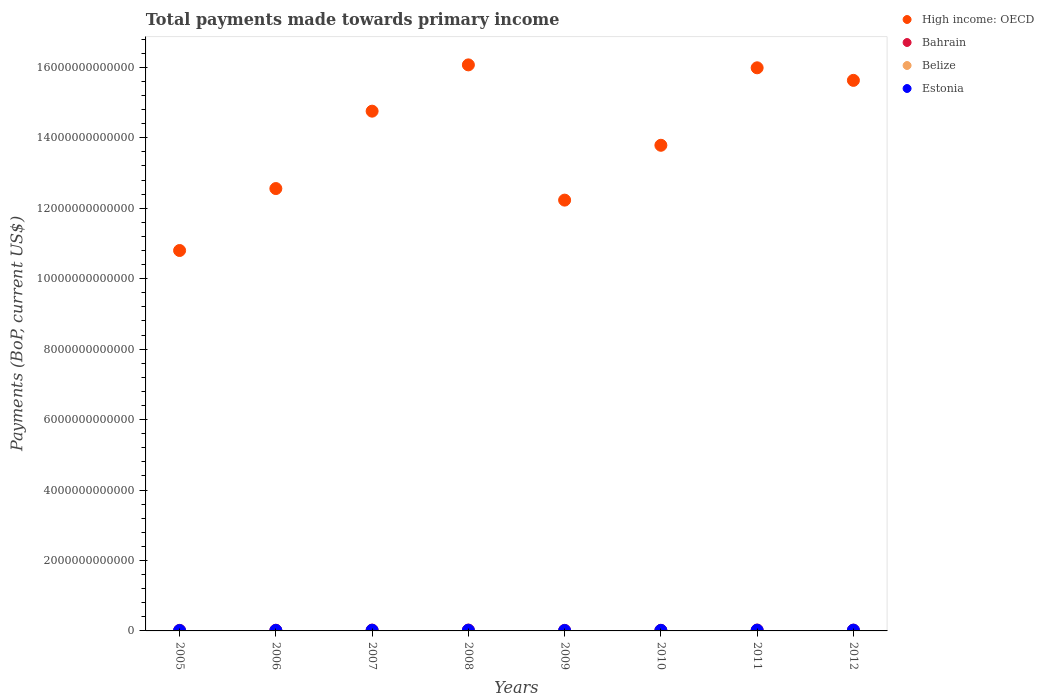What is the total payments made towards primary income in Estonia in 2009?
Make the answer very short. 1.29e+1. Across all years, what is the maximum total payments made towards primary income in Belize?
Give a very brief answer. 1.15e+09. Across all years, what is the minimum total payments made towards primary income in Belize?
Make the answer very short. 8.24e+08. In which year was the total payments made towards primary income in Estonia maximum?
Your response must be concise. 2012. What is the total total payments made towards primary income in Estonia in the graph?
Your answer should be very brief. 1.40e+11. What is the difference between the total payments made towards primary income in Belize in 2008 and that in 2009?
Ensure brevity in your answer.  2.34e+08. What is the difference between the total payments made towards primary income in Belize in 2005 and the total payments made towards primary income in High income: OECD in 2008?
Keep it short and to the point. -1.61e+13. What is the average total payments made towards primary income in Estonia per year?
Make the answer very short. 1.75e+1. In the year 2011, what is the difference between the total payments made towards primary income in Bahrain and total payments made towards primary income in Belize?
Your response must be concise. 2.34e+1. What is the ratio of the total payments made towards primary income in High income: OECD in 2005 to that in 2007?
Provide a succinct answer. 0.73. Is the total payments made towards primary income in High income: OECD in 2005 less than that in 2009?
Make the answer very short. Yes. What is the difference between the highest and the second highest total payments made towards primary income in Belize?
Give a very brief answer. 1.95e+07. What is the difference between the highest and the lowest total payments made towards primary income in High income: OECD?
Provide a succinct answer. 5.27e+12. Is it the case that in every year, the sum of the total payments made towards primary income in Bahrain and total payments made towards primary income in Estonia  is greater than the sum of total payments made towards primary income in High income: OECD and total payments made towards primary income in Belize?
Offer a very short reply. Yes. Does the total payments made towards primary income in High income: OECD monotonically increase over the years?
Offer a very short reply. No. What is the difference between two consecutive major ticks on the Y-axis?
Your response must be concise. 2.00e+12. Where does the legend appear in the graph?
Give a very brief answer. Top right. How are the legend labels stacked?
Make the answer very short. Vertical. What is the title of the graph?
Your answer should be very brief. Total payments made towards primary income. Does "Vanuatu" appear as one of the legend labels in the graph?
Provide a succinct answer. No. What is the label or title of the X-axis?
Your answer should be very brief. Years. What is the label or title of the Y-axis?
Your answer should be compact. Payments (BoP, current US$). What is the Payments (BoP, current US$) of High income: OECD in 2005?
Provide a short and direct response. 1.08e+13. What is the Payments (BoP, current US$) in Bahrain in 2005?
Provide a short and direct response. 1.57e+1. What is the Payments (BoP, current US$) in Belize in 2005?
Give a very brief answer. 8.24e+08. What is the Payments (BoP, current US$) in Estonia in 2005?
Offer a terse response. 1.25e+1. What is the Payments (BoP, current US$) of High income: OECD in 2006?
Your response must be concise. 1.26e+13. What is the Payments (BoP, current US$) in Bahrain in 2006?
Your response must be concise. 1.96e+1. What is the Payments (BoP, current US$) in Belize in 2006?
Offer a very short reply. 8.85e+08. What is the Payments (BoP, current US$) in Estonia in 2006?
Your answer should be compact. 1.56e+1. What is the Payments (BoP, current US$) in High income: OECD in 2007?
Your answer should be compact. 1.48e+13. What is the Payments (BoP, current US$) in Bahrain in 2007?
Provide a succinct answer. 2.33e+1. What is the Payments (BoP, current US$) of Belize in 2007?
Your answer should be very brief. 9.69e+08. What is the Payments (BoP, current US$) of Estonia in 2007?
Give a very brief answer. 1.97e+1. What is the Payments (BoP, current US$) in High income: OECD in 2008?
Your answer should be very brief. 1.61e+13. What is the Payments (BoP, current US$) of Bahrain in 2008?
Your response must be concise. 2.43e+1. What is the Payments (BoP, current US$) of Belize in 2008?
Provide a short and direct response. 1.13e+09. What is the Payments (BoP, current US$) in Estonia in 2008?
Keep it short and to the point. 2.05e+1. What is the Payments (BoP, current US$) in High income: OECD in 2009?
Offer a terse response. 1.22e+13. What is the Payments (BoP, current US$) of Bahrain in 2009?
Keep it short and to the point. 1.54e+1. What is the Payments (BoP, current US$) of Belize in 2009?
Make the answer very short. 8.95e+08. What is the Payments (BoP, current US$) of Estonia in 2009?
Your answer should be very brief. 1.29e+1. What is the Payments (BoP, current US$) of High income: OECD in 2010?
Keep it short and to the point. 1.38e+13. What is the Payments (BoP, current US$) in Bahrain in 2010?
Offer a terse response. 1.69e+1. What is the Payments (BoP, current US$) of Belize in 2010?
Provide a succinct answer. 9.72e+08. What is the Payments (BoP, current US$) in Estonia in 2010?
Make the answer very short. 1.57e+1. What is the Payments (BoP, current US$) of High income: OECD in 2011?
Give a very brief answer. 1.60e+13. What is the Payments (BoP, current US$) in Bahrain in 2011?
Offer a terse response. 2.45e+1. What is the Payments (BoP, current US$) of Belize in 2011?
Your answer should be compact. 1.05e+09. What is the Payments (BoP, current US$) of Estonia in 2011?
Give a very brief answer. 2.14e+1. What is the Payments (BoP, current US$) of High income: OECD in 2012?
Offer a terse response. 1.56e+13. What is the Payments (BoP, current US$) of Bahrain in 2012?
Provide a short and direct response. 2.16e+1. What is the Payments (BoP, current US$) of Belize in 2012?
Make the answer very short. 1.15e+09. What is the Payments (BoP, current US$) of Estonia in 2012?
Provide a short and direct response. 2.21e+1. Across all years, what is the maximum Payments (BoP, current US$) in High income: OECD?
Offer a terse response. 1.61e+13. Across all years, what is the maximum Payments (BoP, current US$) of Bahrain?
Offer a very short reply. 2.45e+1. Across all years, what is the maximum Payments (BoP, current US$) of Belize?
Offer a very short reply. 1.15e+09. Across all years, what is the maximum Payments (BoP, current US$) of Estonia?
Provide a succinct answer. 2.21e+1. Across all years, what is the minimum Payments (BoP, current US$) in High income: OECD?
Offer a terse response. 1.08e+13. Across all years, what is the minimum Payments (BoP, current US$) in Bahrain?
Ensure brevity in your answer.  1.54e+1. Across all years, what is the minimum Payments (BoP, current US$) in Belize?
Keep it short and to the point. 8.24e+08. Across all years, what is the minimum Payments (BoP, current US$) of Estonia?
Make the answer very short. 1.25e+1. What is the total Payments (BoP, current US$) in High income: OECD in the graph?
Provide a succinct answer. 1.12e+14. What is the total Payments (BoP, current US$) of Bahrain in the graph?
Provide a short and direct response. 1.61e+11. What is the total Payments (BoP, current US$) of Belize in the graph?
Make the answer very short. 7.87e+09. What is the total Payments (BoP, current US$) in Estonia in the graph?
Your answer should be compact. 1.40e+11. What is the difference between the Payments (BoP, current US$) in High income: OECD in 2005 and that in 2006?
Provide a succinct answer. -1.76e+12. What is the difference between the Payments (BoP, current US$) in Bahrain in 2005 and that in 2006?
Your answer should be very brief. -3.86e+09. What is the difference between the Payments (BoP, current US$) of Belize in 2005 and that in 2006?
Give a very brief answer. -6.12e+07. What is the difference between the Payments (BoP, current US$) of Estonia in 2005 and that in 2006?
Ensure brevity in your answer.  -3.02e+09. What is the difference between the Payments (BoP, current US$) in High income: OECD in 2005 and that in 2007?
Your answer should be compact. -3.96e+12. What is the difference between the Payments (BoP, current US$) in Bahrain in 2005 and that in 2007?
Offer a terse response. -7.58e+09. What is the difference between the Payments (BoP, current US$) of Belize in 2005 and that in 2007?
Provide a short and direct response. -1.45e+08. What is the difference between the Payments (BoP, current US$) of Estonia in 2005 and that in 2007?
Provide a short and direct response. -7.14e+09. What is the difference between the Payments (BoP, current US$) in High income: OECD in 2005 and that in 2008?
Offer a terse response. -5.27e+12. What is the difference between the Payments (BoP, current US$) in Bahrain in 2005 and that in 2008?
Provide a succinct answer. -8.57e+09. What is the difference between the Payments (BoP, current US$) in Belize in 2005 and that in 2008?
Ensure brevity in your answer.  -3.05e+08. What is the difference between the Payments (BoP, current US$) of Estonia in 2005 and that in 2008?
Keep it short and to the point. -7.98e+09. What is the difference between the Payments (BoP, current US$) in High income: OECD in 2005 and that in 2009?
Offer a terse response. -1.43e+12. What is the difference between the Payments (BoP, current US$) of Bahrain in 2005 and that in 2009?
Provide a succinct answer. 2.81e+08. What is the difference between the Payments (BoP, current US$) in Belize in 2005 and that in 2009?
Make the answer very short. -7.08e+07. What is the difference between the Payments (BoP, current US$) in Estonia in 2005 and that in 2009?
Offer a very short reply. -3.03e+08. What is the difference between the Payments (BoP, current US$) in High income: OECD in 2005 and that in 2010?
Make the answer very short. -2.99e+12. What is the difference between the Payments (BoP, current US$) in Bahrain in 2005 and that in 2010?
Provide a short and direct response. -1.22e+09. What is the difference between the Payments (BoP, current US$) of Belize in 2005 and that in 2010?
Your answer should be compact. -1.48e+08. What is the difference between the Payments (BoP, current US$) in Estonia in 2005 and that in 2010?
Your answer should be compact. -3.12e+09. What is the difference between the Payments (BoP, current US$) of High income: OECD in 2005 and that in 2011?
Make the answer very short. -5.19e+12. What is the difference between the Payments (BoP, current US$) in Bahrain in 2005 and that in 2011?
Your answer should be compact. -8.76e+09. What is the difference between the Payments (BoP, current US$) of Belize in 2005 and that in 2011?
Give a very brief answer. -2.28e+08. What is the difference between the Payments (BoP, current US$) of Estonia in 2005 and that in 2011?
Make the answer very short. -8.81e+09. What is the difference between the Payments (BoP, current US$) in High income: OECD in 2005 and that in 2012?
Provide a succinct answer. -4.83e+12. What is the difference between the Payments (BoP, current US$) of Bahrain in 2005 and that in 2012?
Your response must be concise. -5.84e+09. What is the difference between the Payments (BoP, current US$) in Belize in 2005 and that in 2012?
Keep it short and to the point. -3.24e+08. What is the difference between the Payments (BoP, current US$) of Estonia in 2005 and that in 2012?
Your response must be concise. -9.55e+09. What is the difference between the Payments (BoP, current US$) in High income: OECD in 2006 and that in 2007?
Provide a succinct answer. -2.20e+12. What is the difference between the Payments (BoP, current US$) in Bahrain in 2006 and that in 2007?
Offer a terse response. -3.72e+09. What is the difference between the Payments (BoP, current US$) of Belize in 2006 and that in 2007?
Your answer should be very brief. -8.34e+07. What is the difference between the Payments (BoP, current US$) in Estonia in 2006 and that in 2007?
Ensure brevity in your answer.  -4.11e+09. What is the difference between the Payments (BoP, current US$) of High income: OECD in 2006 and that in 2008?
Offer a very short reply. -3.51e+12. What is the difference between the Payments (BoP, current US$) in Bahrain in 2006 and that in 2008?
Your answer should be very brief. -4.71e+09. What is the difference between the Payments (BoP, current US$) of Belize in 2006 and that in 2008?
Offer a terse response. -2.44e+08. What is the difference between the Payments (BoP, current US$) of Estonia in 2006 and that in 2008?
Give a very brief answer. -4.96e+09. What is the difference between the Payments (BoP, current US$) in High income: OECD in 2006 and that in 2009?
Offer a terse response. 3.28e+11. What is the difference between the Payments (BoP, current US$) of Bahrain in 2006 and that in 2009?
Provide a succinct answer. 4.14e+09. What is the difference between the Payments (BoP, current US$) of Belize in 2006 and that in 2009?
Your answer should be very brief. -9.58e+06. What is the difference between the Payments (BoP, current US$) in Estonia in 2006 and that in 2009?
Make the answer very short. 2.72e+09. What is the difference between the Payments (BoP, current US$) of High income: OECD in 2006 and that in 2010?
Make the answer very short. -1.23e+12. What is the difference between the Payments (BoP, current US$) of Bahrain in 2006 and that in 2010?
Make the answer very short. 2.64e+09. What is the difference between the Payments (BoP, current US$) in Belize in 2006 and that in 2010?
Provide a succinct answer. -8.63e+07. What is the difference between the Payments (BoP, current US$) in Estonia in 2006 and that in 2010?
Offer a very short reply. -9.78e+07. What is the difference between the Payments (BoP, current US$) in High income: OECD in 2006 and that in 2011?
Provide a short and direct response. -3.43e+12. What is the difference between the Payments (BoP, current US$) in Bahrain in 2006 and that in 2011?
Provide a short and direct response. -4.89e+09. What is the difference between the Payments (BoP, current US$) of Belize in 2006 and that in 2011?
Keep it short and to the point. -1.67e+08. What is the difference between the Payments (BoP, current US$) of Estonia in 2006 and that in 2011?
Ensure brevity in your answer.  -5.79e+09. What is the difference between the Payments (BoP, current US$) in High income: OECD in 2006 and that in 2012?
Offer a very short reply. -3.07e+12. What is the difference between the Payments (BoP, current US$) of Bahrain in 2006 and that in 2012?
Offer a terse response. -1.98e+09. What is the difference between the Payments (BoP, current US$) of Belize in 2006 and that in 2012?
Offer a terse response. -2.63e+08. What is the difference between the Payments (BoP, current US$) of Estonia in 2006 and that in 2012?
Keep it short and to the point. -6.52e+09. What is the difference between the Payments (BoP, current US$) of High income: OECD in 2007 and that in 2008?
Make the answer very short. -1.31e+12. What is the difference between the Payments (BoP, current US$) in Bahrain in 2007 and that in 2008?
Offer a very short reply. -9.89e+08. What is the difference between the Payments (BoP, current US$) of Belize in 2007 and that in 2008?
Give a very brief answer. -1.60e+08. What is the difference between the Payments (BoP, current US$) of Estonia in 2007 and that in 2008?
Ensure brevity in your answer.  -8.45e+08. What is the difference between the Payments (BoP, current US$) in High income: OECD in 2007 and that in 2009?
Your response must be concise. 2.53e+12. What is the difference between the Payments (BoP, current US$) in Bahrain in 2007 and that in 2009?
Your response must be concise. 7.86e+09. What is the difference between the Payments (BoP, current US$) in Belize in 2007 and that in 2009?
Provide a short and direct response. 7.38e+07. What is the difference between the Payments (BoP, current US$) in Estonia in 2007 and that in 2009?
Provide a short and direct response. 6.83e+09. What is the difference between the Payments (BoP, current US$) in High income: OECD in 2007 and that in 2010?
Your answer should be compact. 9.68e+11. What is the difference between the Payments (BoP, current US$) in Bahrain in 2007 and that in 2010?
Provide a succinct answer. 6.36e+09. What is the difference between the Payments (BoP, current US$) of Belize in 2007 and that in 2010?
Give a very brief answer. -2.94e+06. What is the difference between the Payments (BoP, current US$) in Estonia in 2007 and that in 2010?
Keep it short and to the point. 4.01e+09. What is the difference between the Payments (BoP, current US$) of High income: OECD in 2007 and that in 2011?
Your answer should be very brief. -1.23e+12. What is the difference between the Payments (BoP, current US$) of Bahrain in 2007 and that in 2011?
Your answer should be compact. -1.17e+09. What is the difference between the Payments (BoP, current US$) in Belize in 2007 and that in 2011?
Offer a very short reply. -8.34e+07. What is the difference between the Payments (BoP, current US$) in Estonia in 2007 and that in 2011?
Give a very brief answer. -1.67e+09. What is the difference between the Payments (BoP, current US$) in High income: OECD in 2007 and that in 2012?
Offer a very short reply. -8.74e+11. What is the difference between the Payments (BoP, current US$) in Bahrain in 2007 and that in 2012?
Make the answer very short. 1.74e+09. What is the difference between the Payments (BoP, current US$) in Belize in 2007 and that in 2012?
Give a very brief answer. -1.80e+08. What is the difference between the Payments (BoP, current US$) in Estonia in 2007 and that in 2012?
Your answer should be very brief. -2.41e+09. What is the difference between the Payments (BoP, current US$) in High income: OECD in 2008 and that in 2009?
Make the answer very short. 3.84e+12. What is the difference between the Payments (BoP, current US$) of Bahrain in 2008 and that in 2009?
Your answer should be very brief. 8.85e+09. What is the difference between the Payments (BoP, current US$) of Belize in 2008 and that in 2009?
Ensure brevity in your answer.  2.34e+08. What is the difference between the Payments (BoP, current US$) in Estonia in 2008 and that in 2009?
Provide a short and direct response. 7.68e+09. What is the difference between the Payments (BoP, current US$) of High income: OECD in 2008 and that in 2010?
Keep it short and to the point. 2.28e+12. What is the difference between the Payments (BoP, current US$) in Bahrain in 2008 and that in 2010?
Provide a short and direct response. 7.35e+09. What is the difference between the Payments (BoP, current US$) of Belize in 2008 and that in 2010?
Provide a short and direct response. 1.57e+08. What is the difference between the Payments (BoP, current US$) of Estonia in 2008 and that in 2010?
Provide a short and direct response. 4.86e+09. What is the difference between the Payments (BoP, current US$) of High income: OECD in 2008 and that in 2011?
Keep it short and to the point. 8.32e+1. What is the difference between the Payments (BoP, current US$) of Bahrain in 2008 and that in 2011?
Your answer should be very brief. -1.82e+08. What is the difference between the Payments (BoP, current US$) of Belize in 2008 and that in 2011?
Your answer should be compact. 7.67e+07. What is the difference between the Payments (BoP, current US$) of Estonia in 2008 and that in 2011?
Your response must be concise. -8.30e+08. What is the difference between the Payments (BoP, current US$) of High income: OECD in 2008 and that in 2012?
Your response must be concise. 4.40e+11. What is the difference between the Payments (BoP, current US$) in Bahrain in 2008 and that in 2012?
Your response must be concise. 2.73e+09. What is the difference between the Payments (BoP, current US$) of Belize in 2008 and that in 2012?
Your answer should be compact. -1.95e+07. What is the difference between the Payments (BoP, current US$) in Estonia in 2008 and that in 2012?
Make the answer very short. -1.57e+09. What is the difference between the Payments (BoP, current US$) in High income: OECD in 2009 and that in 2010?
Offer a terse response. -1.56e+12. What is the difference between the Payments (BoP, current US$) in Bahrain in 2009 and that in 2010?
Make the answer very short. -1.50e+09. What is the difference between the Payments (BoP, current US$) in Belize in 2009 and that in 2010?
Your response must be concise. -7.67e+07. What is the difference between the Payments (BoP, current US$) of Estonia in 2009 and that in 2010?
Your answer should be very brief. -2.82e+09. What is the difference between the Payments (BoP, current US$) of High income: OECD in 2009 and that in 2011?
Offer a terse response. -3.76e+12. What is the difference between the Payments (BoP, current US$) of Bahrain in 2009 and that in 2011?
Provide a short and direct response. -9.04e+09. What is the difference between the Payments (BoP, current US$) in Belize in 2009 and that in 2011?
Your response must be concise. -1.57e+08. What is the difference between the Payments (BoP, current US$) of Estonia in 2009 and that in 2011?
Your response must be concise. -8.51e+09. What is the difference between the Payments (BoP, current US$) in High income: OECD in 2009 and that in 2012?
Offer a terse response. -3.40e+12. What is the difference between the Payments (BoP, current US$) of Bahrain in 2009 and that in 2012?
Provide a succinct answer. -6.12e+09. What is the difference between the Payments (BoP, current US$) of Belize in 2009 and that in 2012?
Give a very brief answer. -2.53e+08. What is the difference between the Payments (BoP, current US$) in Estonia in 2009 and that in 2012?
Offer a very short reply. -9.24e+09. What is the difference between the Payments (BoP, current US$) of High income: OECD in 2010 and that in 2011?
Keep it short and to the point. -2.20e+12. What is the difference between the Payments (BoP, current US$) of Bahrain in 2010 and that in 2011?
Keep it short and to the point. -7.53e+09. What is the difference between the Payments (BoP, current US$) of Belize in 2010 and that in 2011?
Your answer should be very brief. -8.05e+07. What is the difference between the Payments (BoP, current US$) in Estonia in 2010 and that in 2011?
Your response must be concise. -5.69e+09. What is the difference between the Payments (BoP, current US$) of High income: OECD in 2010 and that in 2012?
Provide a short and direct response. -1.84e+12. What is the difference between the Payments (BoP, current US$) in Bahrain in 2010 and that in 2012?
Provide a short and direct response. -4.62e+09. What is the difference between the Payments (BoP, current US$) in Belize in 2010 and that in 2012?
Your response must be concise. -1.77e+08. What is the difference between the Payments (BoP, current US$) of Estonia in 2010 and that in 2012?
Your answer should be compact. -6.42e+09. What is the difference between the Payments (BoP, current US$) of High income: OECD in 2011 and that in 2012?
Your answer should be very brief. 3.56e+11. What is the difference between the Payments (BoP, current US$) of Bahrain in 2011 and that in 2012?
Offer a terse response. 2.92e+09. What is the difference between the Payments (BoP, current US$) in Belize in 2011 and that in 2012?
Your response must be concise. -9.62e+07. What is the difference between the Payments (BoP, current US$) in Estonia in 2011 and that in 2012?
Offer a terse response. -7.37e+08. What is the difference between the Payments (BoP, current US$) of High income: OECD in 2005 and the Payments (BoP, current US$) of Bahrain in 2006?
Ensure brevity in your answer.  1.08e+13. What is the difference between the Payments (BoP, current US$) of High income: OECD in 2005 and the Payments (BoP, current US$) of Belize in 2006?
Your response must be concise. 1.08e+13. What is the difference between the Payments (BoP, current US$) of High income: OECD in 2005 and the Payments (BoP, current US$) of Estonia in 2006?
Make the answer very short. 1.08e+13. What is the difference between the Payments (BoP, current US$) of Bahrain in 2005 and the Payments (BoP, current US$) of Belize in 2006?
Offer a very short reply. 1.48e+1. What is the difference between the Payments (BoP, current US$) of Bahrain in 2005 and the Payments (BoP, current US$) of Estonia in 2006?
Offer a very short reply. 1.42e+08. What is the difference between the Payments (BoP, current US$) in Belize in 2005 and the Payments (BoP, current US$) in Estonia in 2006?
Make the answer very short. -1.47e+1. What is the difference between the Payments (BoP, current US$) of High income: OECD in 2005 and the Payments (BoP, current US$) of Bahrain in 2007?
Make the answer very short. 1.08e+13. What is the difference between the Payments (BoP, current US$) in High income: OECD in 2005 and the Payments (BoP, current US$) in Belize in 2007?
Keep it short and to the point. 1.08e+13. What is the difference between the Payments (BoP, current US$) in High income: OECD in 2005 and the Payments (BoP, current US$) in Estonia in 2007?
Make the answer very short. 1.08e+13. What is the difference between the Payments (BoP, current US$) in Bahrain in 2005 and the Payments (BoP, current US$) in Belize in 2007?
Make the answer very short. 1.47e+1. What is the difference between the Payments (BoP, current US$) in Bahrain in 2005 and the Payments (BoP, current US$) in Estonia in 2007?
Your answer should be very brief. -3.97e+09. What is the difference between the Payments (BoP, current US$) in Belize in 2005 and the Payments (BoP, current US$) in Estonia in 2007?
Provide a succinct answer. -1.89e+1. What is the difference between the Payments (BoP, current US$) in High income: OECD in 2005 and the Payments (BoP, current US$) in Bahrain in 2008?
Keep it short and to the point. 1.08e+13. What is the difference between the Payments (BoP, current US$) in High income: OECD in 2005 and the Payments (BoP, current US$) in Belize in 2008?
Your response must be concise. 1.08e+13. What is the difference between the Payments (BoP, current US$) of High income: OECD in 2005 and the Payments (BoP, current US$) of Estonia in 2008?
Make the answer very short. 1.08e+13. What is the difference between the Payments (BoP, current US$) in Bahrain in 2005 and the Payments (BoP, current US$) in Belize in 2008?
Your answer should be very brief. 1.46e+1. What is the difference between the Payments (BoP, current US$) in Bahrain in 2005 and the Payments (BoP, current US$) in Estonia in 2008?
Provide a short and direct response. -4.81e+09. What is the difference between the Payments (BoP, current US$) of Belize in 2005 and the Payments (BoP, current US$) of Estonia in 2008?
Offer a terse response. -1.97e+1. What is the difference between the Payments (BoP, current US$) in High income: OECD in 2005 and the Payments (BoP, current US$) in Bahrain in 2009?
Provide a succinct answer. 1.08e+13. What is the difference between the Payments (BoP, current US$) in High income: OECD in 2005 and the Payments (BoP, current US$) in Belize in 2009?
Offer a terse response. 1.08e+13. What is the difference between the Payments (BoP, current US$) in High income: OECD in 2005 and the Payments (BoP, current US$) in Estonia in 2009?
Offer a very short reply. 1.08e+13. What is the difference between the Payments (BoP, current US$) of Bahrain in 2005 and the Payments (BoP, current US$) of Belize in 2009?
Give a very brief answer. 1.48e+1. What is the difference between the Payments (BoP, current US$) of Bahrain in 2005 and the Payments (BoP, current US$) of Estonia in 2009?
Give a very brief answer. 2.86e+09. What is the difference between the Payments (BoP, current US$) in Belize in 2005 and the Payments (BoP, current US$) in Estonia in 2009?
Make the answer very short. -1.20e+1. What is the difference between the Payments (BoP, current US$) of High income: OECD in 2005 and the Payments (BoP, current US$) of Bahrain in 2010?
Offer a very short reply. 1.08e+13. What is the difference between the Payments (BoP, current US$) of High income: OECD in 2005 and the Payments (BoP, current US$) of Belize in 2010?
Your response must be concise. 1.08e+13. What is the difference between the Payments (BoP, current US$) in High income: OECD in 2005 and the Payments (BoP, current US$) in Estonia in 2010?
Your answer should be very brief. 1.08e+13. What is the difference between the Payments (BoP, current US$) of Bahrain in 2005 and the Payments (BoP, current US$) of Belize in 2010?
Your answer should be compact. 1.47e+1. What is the difference between the Payments (BoP, current US$) in Bahrain in 2005 and the Payments (BoP, current US$) in Estonia in 2010?
Your answer should be compact. 4.45e+07. What is the difference between the Payments (BoP, current US$) in Belize in 2005 and the Payments (BoP, current US$) in Estonia in 2010?
Your answer should be very brief. -1.48e+1. What is the difference between the Payments (BoP, current US$) in High income: OECD in 2005 and the Payments (BoP, current US$) in Bahrain in 2011?
Your answer should be very brief. 1.08e+13. What is the difference between the Payments (BoP, current US$) in High income: OECD in 2005 and the Payments (BoP, current US$) in Belize in 2011?
Give a very brief answer. 1.08e+13. What is the difference between the Payments (BoP, current US$) in High income: OECD in 2005 and the Payments (BoP, current US$) in Estonia in 2011?
Your answer should be very brief. 1.08e+13. What is the difference between the Payments (BoP, current US$) in Bahrain in 2005 and the Payments (BoP, current US$) in Belize in 2011?
Your answer should be compact. 1.47e+1. What is the difference between the Payments (BoP, current US$) of Bahrain in 2005 and the Payments (BoP, current US$) of Estonia in 2011?
Ensure brevity in your answer.  -5.64e+09. What is the difference between the Payments (BoP, current US$) in Belize in 2005 and the Payments (BoP, current US$) in Estonia in 2011?
Give a very brief answer. -2.05e+1. What is the difference between the Payments (BoP, current US$) of High income: OECD in 2005 and the Payments (BoP, current US$) of Bahrain in 2012?
Provide a short and direct response. 1.08e+13. What is the difference between the Payments (BoP, current US$) in High income: OECD in 2005 and the Payments (BoP, current US$) in Belize in 2012?
Ensure brevity in your answer.  1.08e+13. What is the difference between the Payments (BoP, current US$) of High income: OECD in 2005 and the Payments (BoP, current US$) of Estonia in 2012?
Offer a terse response. 1.08e+13. What is the difference between the Payments (BoP, current US$) of Bahrain in 2005 and the Payments (BoP, current US$) of Belize in 2012?
Offer a very short reply. 1.46e+1. What is the difference between the Payments (BoP, current US$) in Bahrain in 2005 and the Payments (BoP, current US$) in Estonia in 2012?
Your answer should be compact. -6.38e+09. What is the difference between the Payments (BoP, current US$) in Belize in 2005 and the Payments (BoP, current US$) in Estonia in 2012?
Your response must be concise. -2.13e+1. What is the difference between the Payments (BoP, current US$) of High income: OECD in 2006 and the Payments (BoP, current US$) of Bahrain in 2007?
Ensure brevity in your answer.  1.25e+13. What is the difference between the Payments (BoP, current US$) in High income: OECD in 2006 and the Payments (BoP, current US$) in Belize in 2007?
Offer a very short reply. 1.26e+13. What is the difference between the Payments (BoP, current US$) in High income: OECD in 2006 and the Payments (BoP, current US$) in Estonia in 2007?
Make the answer very short. 1.25e+13. What is the difference between the Payments (BoP, current US$) in Bahrain in 2006 and the Payments (BoP, current US$) in Belize in 2007?
Offer a very short reply. 1.86e+1. What is the difference between the Payments (BoP, current US$) in Bahrain in 2006 and the Payments (BoP, current US$) in Estonia in 2007?
Make the answer very short. -1.06e+08. What is the difference between the Payments (BoP, current US$) in Belize in 2006 and the Payments (BoP, current US$) in Estonia in 2007?
Offer a very short reply. -1.88e+1. What is the difference between the Payments (BoP, current US$) of High income: OECD in 2006 and the Payments (BoP, current US$) of Bahrain in 2008?
Your answer should be compact. 1.25e+13. What is the difference between the Payments (BoP, current US$) in High income: OECD in 2006 and the Payments (BoP, current US$) in Belize in 2008?
Ensure brevity in your answer.  1.26e+13. What is the difference between the Payments (BoP, current US$) of High income: OECD in 2006 and the Payments (BoP, current US$) of Estonia in 2008?
Ensure brevity in your answer.  1.25e+13. What is the difference between the Payments (BoP, current US$) of Bahrain in 2006 and the Payments (BoP, current US$) of Belize in 2008?
Offer a terse response. 1.84e+1. What is the difference between the Payments (BoP, current US$) in Bahrain in 2006 and the Payments (BoP, current US$) in Estonia in 2008?
Give a very brief answer. -9.51e+08. What is the difference between the Payments (BoP, current US$) of Belize in 2006 and the Payments (BoP, current US$) of Estonia in 2008?
Offer a terse response. -1.96e+1. What is the difference between the Payments (BoP, current US$) of High income: OECD in 2006 and the Payments (BoP, current US$) of Bahrain in 2009?
Offer a terse response. 1.25e+13. What is the difference between the Payments (BoP, current US$) of High income: OECD in 2006 and the Payments (BoP, current US$) of Belize in 2009?
Keep it short and to the point. 1.26e+13. What is the difference between the Payments (BoP, current US$) of High income: OECD in 2006 and the Payments (BoP, current US$) of Estonia in 2009?
Offer a terse response. 1.25e+13. What is the difference between the Payments (BoP, current US$) in Bahrain in 2006 and the Payments (BoP, current US$) in Belize in 2009?
Your response must be concise. 1.87e+1. What is the difference between the Payments (BoP, current US$) in Bahrain in 2006 and the Payments (BoP, current US$) in Estonia in 2009?
Your response must be concise. 6.73e+09. What is the difference between the Payments (BoP, current US$) in Belize in 2006 and the Payments (BoP, current US$) in Estonia in 2009?
Keep it short and to the point. -1.20e+1. What is the difference between the Payments (BoP, current US$) of High income: OECD in 2006 and the Payments (BoP, current US$) of Bahrain in 2010?
Keep it short and to the point. 1.25e+13. What is the difference between the Payments (BoP, current US$) in High income: OECD in 2006 and the Payments (BoP, current US$) in Belize in 2010?
Your answer should be very brief. 1.26e+13. What is the difference between the Payments (BoP, current US$) in High income: OECD in 2006 and the Payments (BoP, current US$) in Estonia in 2010?
Provide a succinct answer. 1.25e+13. What is the difference between the Payments (BoP, current US$) of Bahrain in 2006 and the Payments (BoP, current US$) of Belize in 2010?
Provide a succinct answer. 1.86e+1. What is the difference between the Payments (BoP, current US$) in Bahrain in 2006 and the Payments (BoP, current US$) in Estonia in 2010?
Your answer should be very brief. 3.91e+09. What is the difference between the Payments (BoP, current US$) in Belize in 2006 and the Payments (BoP, current US$) in Estonia in 2010?
Give a very brief answer. -1.48e+1. What is the difference between the Payments (BoP, current US$) in High income: OECD in 2006 and the Payments (BoP, current US$) in Bahrain in 2011?
Ensure brevity in your answer.  1.25e+13. What is the difference between the Payments (BoP, current US$) in High income: OECD in 2006 and the Payments (BoP, current US$) in Belize in 2011?
Offer a very short reply. 1.26e+13. What is the difference between the Payments (BoP, current US$) of High income: OECD in 2006 and the Payments (BoP, current US$) of Estonia in 2011?
Offer a terse response. 1.25e+13. What is the difference between the Payments (BoP, current US$) of Bahrain in 2006 and the Payments (BoP, current US$) of Belize in 2011?
Your response must be concise. 1.85e+1. What is the difference between the Payments (BoP, current US$) of Bahrain in 2006 and the Payments (BoP, current US$) of Estonia in 2011?
Your response must be concise. -1.78e+09. What is the difference between the Payments (BoP, current US$) of Belize in 2006 and the Payments (BoP, current US$) of Estonia in 2011?
Make the answer very short. -2.05e+1. What is the difference between the Payments (BoP, current US$) of High income: OECD in 2006 and the Payments (BoP, current US$) of Bahrain in 2012?
Provide a succinct answer. 1.25e+13. What is the difference between the Payments (BoP, current US$) in High income: OECD in 2006 and the Payments (BoP, current US$) in Belize in 2012?
Offer a terse response. 1.26e+13. What is the difference between the Payments (BoP, current US$) in High income: OECD in 2006 and the Payments (BoP, current US$) in Estonia in 2012?
Give a very brief answer. 1.25e+13. What is the difference between the Payments (BoP, current US$) of Bahrain in 2006 and the Payments (BoP, current US$) of Belize in 2012?
Offer a terse response. 1.84e+1. What is the difference between the Payments (BoP, current US$) of Bahrain in 2006 and the Payments (BoP, current US$) of Estonia in 2012?
Your answer should be compact. -2.52e+09. What is the difference between the Payments (BoP, current US$) in Belize in 2006 and the Payments (BoP, current US$) in Estonia in 2012?
Provide a short and direct response. -2.12e+1. What is the difference between the Payments (BoP, current US$) in High income: OECD in 2007 and the Payments (BoP, current US$) in Bahrain in 2008?
Offer a terse response. 1.47e+13. What is the difference between the Payments (BoP, current US$) of High income: OECD in 2007 and the Payments (BoP, current US$) of Belize in 2008?
Your response must be concise. 1.48e+13. What is the difference between the Payments (BoP, current US$) of High income: OECD in 2007 and the Payments (BoP, current US$) of Estonia in 2008?
Provide a short and direct response. 1.47e+13. What is the difference between the Payments (BoP, current US$) in Bahrain in 2007 and the Payments (BoP, current US$) in Belize in 2008?
Keep it short and to the point. 2.22e+1. What is the difference between the Payments (BoP, current US$) of Bahrain in 2007 and the Payments (BoP, current US$) of Estonia in 2008?
Your answer should be very brief. 2.77e+09. What is the difference between the Payments (BoP, current US$) of Belize in 2007 and the Payments (BoP, current US$) of Estonia in 2008?
Give a very brief answer. -1.96e+1. What is the difference between the Payments (BoP, current US$) in High income: OECD in 2007 and the Payments (BoP, current US$) in Bahrain in 2009?
Make the answer very short. 1.47e+13. What is the difference between the Payments (BoP, current US$) in High income: OECD in 2007 and the Payments (BoP, current US$) in Belize in 2009?
Provide a short and direct response. 1.48e+13. What is the difference between the Payments (BoP, current US$) in High income: OECD in 2007 and the Payments (BoP, current US$) in Estonia in 2009?
Make the answer very short. 1.47e+13. What is the difference between the Payments (BoP, current US$) of Bahrain in 2007 and the Payments (BoP, current US$) of Belize in 2009?
Your answer should be compact. 2.24e+1. What is the difference between the Payments (BoP, current US$) in Bahrain in 2007 and the Payments (BoP, current US$) in Estonia in 2009?
Your answer should be compact. 1.04e+1. What is the difference between the Payments (BoP, current US$) of Belize in 2007 and the Payments (BoP, current US$) of Estonia in 2009?
Offer a very short reply. -1.19e+1. What is the difference between the Payments (BoP, current US$) in High income: OECD in 2007 and the Payments (BoP, current US$) in Bahrain in 2010?
Offer a terse response. 1.47e+13. What is the difference between the Payments (BoP, current US$) in High income: OECD in 2007 and the Payments (BoP, current US$) in Belize in 2010?
Offer a very short reply. 1.48e+13. What is the difference between the Payments (BoP, current US$) in High income: OECD in 2007 and the Payments (BoP, current US$) in Estonia in 2010?
Provide a succinct answer. 1.47e+13. What is the difference between the Payments (BoP, current US$) in Bahrain in 2007 and the Payments (BoP, current US$) in Belize in 2010?
Ensure brevity in your answer.  2.23e+1. What is the difference between the Payments (BoP, current US$) of Bahrain in 2007 and the Payments (BoP, current US$) of Estonia in 2010?
Offer a terse response. 7.63e+09. What is the difference between the Payments (BoP, current US$) in Belize in 2007 and the Payments (BoP, current US$) in Estonia in 2010?
Make the answer very short. -1.47e+1. What is the difference between the Payments (BoP, current US$) in High income: OECD in 2007 and the Payments (BoP, current US$) in Bahrain in 2011?
Offer a very short reply. 1.47e+13. What is the difference between the Payments (BoP, current US$) of High income: OECD in 2007 and the Payments (BoP, current US$) of Belize in 2011?
Offer a terse response. 1.48e+13. What is the difference between the Payments (BoP, current US$) in High income: OECD in 2007 and the Payments (BoP, current US$) in Estonia in 2011?
Keep it short and to the point. 1.47e+13. What is the difference between the Payments (BoP, current US$) in Bahrain in 2007 and the Payments (BoP, current US$) in Belize in 2011?
Your answer should be very brief. 2.22e+1. What is the difference between the Payments (BoP, current US$) of Bahrain in 2007 and the Payments (BoP, current US$) of Estonia in 2011?
Offer a terse response. 1.94e+09. What is the difference between the Payments (BoP, current US$) in Belize in 2007 and the Payments (BoP, current US$) in Estonia in 2011?
Your answer should be compact. -2.04e+1. What is the difference between the Payments (BoP, current US$) in High income: OECD in 2007 and the Payments (BoP, current US$) in Bahrain in 2012?
Keep it short and to the point. 1.47e+13. What is the difference between the Payments (BoP, current US$) in High income: OECD in 2007 and the Payments (BoP, current US$) in Belize in 2012?
Provide a succinct answer. 1.48e+13. What is the difference between the Payments (BoP, current US$) of High income: OECD in 2007 and the Payments (BoP, current US$) of Estonia in 2012?
Your answer should be very brief. 1.47e+13. What is the difference between the Payments (BoP, current US$) in Bahrain in 2007 and the Payments (BoP, current US$) in Belize in 2012?
Make the answer very short. 2.22e+1. What is the difference between the Payments (BoP, current US$) in Bahrain in 2007 and the Payments (BoP, current US$) in Estonia in 2012?
Offer a terse response. 1.20e+09. What is the difference between the Payments (BoP, current US$) of Belize in 2007 and the Payments (BoP, current US$) of Estonia in 2012?
Make the answer very short. -2.11e+1. What is the difference between the Payments (BoP, current US$) of High income: OECD in 2008 and the Payments (BoP, current US$) of Bahrain in 2009?
Provide a short and direct response. 1.61e+13. What is the difference between the Payments (BoP, current US$) of High income: OECD in 2008 and the Payments (BoP, current US$) of Belize in 2009?
Provide a short and direct response. 1.61e+13. What is the difference between the Payments (BoP, current US$) in High income: OECD in 2008 and the Payments (BoP, current US$) in Estonia in 2009?
Keep it short and to the point. 1.61e+13. What is the difference between the Payments (BoP, current US$) in Bahrain in 2008 and the Payments (BoP, current US$) in Belize in 2009?
Your response must be concise. 2.34e+1. What is the difference between the Payments (BoP, current US$) in Bahrain in 2008 and the Payments (BoP, current US$) in Estonia in 2009?
Provide a short and direct response. 1.14e+1. What is the difference between the Payments (BoP, current US$) of Belize in 2008 and the Payments (BoP, current US$) of Estonia in 2009?
Your answer should be very brief. -1.17e+1. What is the difference between the Payments (BoP, current US$) in High income: OECD in 2008 and the Payments (BoP, current US$) in Bahrain in 2010?
Provide a short and direct response. 1.61e+13. What is the difference between the Payments (BoP, current US$) of High income: OECD in 2008 and the Payments (BoP, current US$) of Belize in 2010?
Offer a very short reply. 1.61e+13. What is the difference between the Payments (BoP, current US$) of High income: OECD in 2008 and the Payments (BoP, current US$) of Estonia in 2010?
Make the answer very short. 1.61e+13. What is the difference between the Payments (BoP, current US$) of Bahrain in 2008 and the Payments (BoP, current US$) of Belize in 2010?
Offer a terse response. 2.33e+1. What is the difference between the Payments (BoP, current US$) in Bahrain in 2008 and the Payments (BoP, current US$) in Estonia in 2010?
Provide a short and direct response. 8.62e+09. What is the difference between the Payments (BoP, current US$) in Belize in 2008 and the Payments (BoP, current US$) in Estonia in 2010?
Make the answer very short. -1.45e+1. What is the difference between the Payments (BoP, current US$) in High income: OECD in 2008 and the Payments (BoP, current US$) in Bahrain in 2011?
Provide a short and direct response. 1.60e+13. What is the difference between the Payments (BoP, current US$) in High income: OECD in 2008 and the Payments (BoP, current US$) in Belize in 2011?
Provide a short and direct response. 1.61e+13. What is the difference between the Payments (BoP, current US$) of High income: OECD in 2008 and the Payments (BoP, current US$) of Estonia in 2011?
Your answer should be very brief. 1.60e+13. What is the difference between the Payments (BoP, current US$) of Bahrain in 2008 and the Payments (BoP, current US$) of Belize in 2011?
Make the answer very short. 2.32e+1. What is the difference between the Payments (BoP, current US$) of Bahrain in 2008 and the Payments (BoP, current US$) of Estonia in 2011?
Offer a terse response. 2.93e+09. What is the difference between the Payments (BoP, current US$) in Belize in 2008 and the Payments (BoP, current US$) in Estonia in 2011?
Keep it short and to the point. -2.02e+1. What is the difference between the Payments (BoP, current US$) of High income: OECD in 2008 and the Payments (BoP, current US$) of Bahrain in 2012?
Make the answer very short. 1.60e+13. What is the difference between the Payments (BoP, current US$) of High income: OECD in 2008 and the Payments (BoP, current US$) of Belize in 2012?
Your answer should be compact. 1.61e+13. What is the difference between the Payments (BoP, current US$) in High income: OECD in 2008 and the Payments (BoP, current US$) in Estonia in 2012?
Make the answer very short. 1.60e+13. What is the difference between the Payments (BoP, current US$) in Bahrain in 2008 and the Payments (BoP, current US$) in Belize in 2012?
Give a very brief answer. 2.31e+1. What is the difference between the Payments (BoP, current US$) of Bahrain in 2008 and the Payments (BoP, current US$) of Estonia in 2012?
Ensure brevity in your answer.  2.19e+09. What is the difference between the Payments (BoP, current US$) of Belize in 2008 and the Payments (BoP, current US$) of Estonia in 2012?
Provide a succinct answer. -2.10e+1. What is the difference between the Payments (BoP, current US$) in High income: OECD in 2009 and the Payments (BoP, current US$) in Bahrain in 2010?
Make the answer very short. 1.22e+13. What is the difference between the Payments (BoP, current US$) in High income: OECD in 2009 and the Payments (BoP, current US$) in Belize in 2010?
Your answer should be compact. 1.22e+13. What is the difference between the Payments (BoP, current US$) in High income: OECD in 2009 and the Payments (BoP, current US$) in Estonia in 2010?
Keep it short and to the point. 1.22e+13. What is the difference between the Payments (BoP, current US$) of Bahrain in 2009 and the Payments (BoP, current US$) of Belize in 2010?
Your response must be concise. 1.45e+1. What is the difference between the Payments (BoP, current US$) of Bahrain in 2009 and the Payments (BoP, current US$) of Estonia in 2010?
Offer a terse response. -2.37e+08. What is the difference between the Payments (BoP, current US$) in Belize in 2009 and the Payments (BoP, current US$) in Estonia in 2010?
Provide a succinct answer. -1.48e+1. What is the difference between the Payments (BoP, current US$) of High income: OECD in 2009 and the Payments (BoP, current US$) of Bahrain in 2011?
Your answer should be very brief. 1.22e+13. What is the difference between the Payments (BoP, current US$) in High income: OECD in 2009 and the Payments (BoP, current US$) in Belize in 2011?
Provide a succinct answer. 1.22e+13. What is the difference between the Payments (BoP, current US$) of High income: OECD in 2009 and the Payments (BoP, current US$) of Estonia in 2011?
Provide a short and direct response. 1.22e+13. What is the difference between the Payments (BoP, current US$) in Bahrain in 2009 and the Payments (BoP, current US$) in Belize in 2011?
Give a very brief answer. 1.44e+1. What is the difference between the Payments (BoP, current US$) in Bahrain in 2009 and the Payments (BoP, current US$) in Estonia in 2011?
Ensure brevity in your answer.  -5.92e+09. What is the difference between the Payments (BoP, current US$) in Belize in 2009 and the Payments (BoP, current US$) in Estonia in 2011?
Offer a very short reply. -2.05e+1. What is the difference between the Payments (BoP, current US$) in High income: OECD in 2009 and the Payments (BoP, current US$) in Bahrain in 2012?
Your answer should be very brief. 1.22e+13. What is the difference between the Payments (BoP, current US$) of High income: OECD in 2009 and the Payments (BoP, current US$) of Belize in 2012?
Ensure brevity in your answer.  1.22e+13. What is the difference between the Payments (BoP, current US$) of High income: OECD in 2009 and the Payments (BoP, current US$) of Estonia in 2012?
Provide a short and direct response. 1.22e+13. What is the difference between the Payments (BoP, current US$) in Bahrain in 2009 and the Payments (BoP, current US$) in Belize in 2012?
Your answer should be compact. 1.43e+1. What is the difference between the Payments (BoP, current US$) in Bahrain in 2009 and the Payments (BoP, current US$) in Estonia in 2012?
Ensure brevity in your answer.  -6.66e+09. What is the difference between the Payments (BoP, current US$) in Belize in 2009 and the Payments (BoP, current US$) in Estonia in 2012?
Your answer should be very brief. -2.12e+1. What is the difference between the Payments (BoP, current US$) of High income: OECD in 2010 and the Payments (BoP, current US$) of Bahrain in 2011?
Offer a terse response. 1.38e+13. What is the difference between the Payments (BoP, current US$) in High income: OECD in 2010 and the Payments (BoP, current US$) in Belize in 2011?
Give a very brief answer. 1.38e+13. What is the difference between the Payments (BoP, current US$) in High income: OECD in 2010 and the Payments (BoP, current US$) in Estonia in 2011?
Provide a short and direct response. 1.38e+13. What is the difference between the Payments (BoP, current US$) of Bahrain in 2010 and the Payments (BoP, current US$) of Belize in 2011?
Ensure brevity in your answer.  1.59e+1. What is the difference between the Payments (BoP, current US$) of Bahrain in 2010 and the Payments (BoP, current US$) of Estonia in 2011?
Offer a very short reply. -4.42e+09. What is the difference between the Payments (BoP, current US$) of Belize in 2010 and the Payments (BoP, current US$) of Estonia in 2011?
Give a very brief answer. -2.04e+1. What is the difference between the Payments (BoP, current US$) of High income: OECD in 2010 and the Payments (BoP, current US$) of Bahrain in 2012?
Offer a very short reply. 1.38e+13. What is the difference between the Payments (BoP, current US$) in High income: OECD in 2010 and the Payments (BoP, current US$) in Belize in 2012?
Keep it short and to the point. 1.38e+13. What is the difference between the Payments (BoP, current US$) in High income: OECD in 2010 and the Payments (BoP, current US$) in Estonia in 2012?
Make the answer very short. 1.38e+13. What is the difference between the Payments (BoP, current US$) in Bahrain in 2010 and the Payments (BoP, current US$) in Belize in 2012?
Give a very brief answer. 1.58e+1. What is the difference between the Payments (BoP, current US$) in Bahrain in 2010 and the Payments (BoP, current US$) in Estonia in 2012?
Give a very brief answer. -5.16e+09. What is the difference between the Payments (BoP, current US$) of Belize in 2010 and the Payments (BoP, current US$) of Estonia in 2012?
Your response must be concise. -2.11e+1. What is the difference between the Payments (BoP, current US$) of High income: OECD in 2011 and the Payments (BoP, current US$) of Bahrain in 2012?
Your answer should be very brief. 1.60e+13. What is the difference between the Payments (BoP, current US$) of High income: OECD in 2011 and the Payments (BoP, current US$) of Belize in 2012?
Give a very brief answer. 1.60e+13. What is the difference between the Payments (BoP, current US$) of High income: OECD in 2011 and the Payments (BoP, current US$) of Estonia in 2012?
Your answer should be compact. 1.60e+13. What is the difference between the Payments (BoP, current US$) of Bahrain in 2011 and the Payments (BoP, current US$) of Belize in 2012?
Offer a very short reply. 2.33e+1. What is the difference between the Payments (BoP, current US$) in Bahrain in 2011 and the Payments (BoP, current US$) in Estonia in 2012?
Keep it short and to the point. 2.38e+09. What is the difference between the Payments (BoP, current US$) of Belize in 2011 and the Payments (BoP, current US$) of Estonia in 2012?
Your response must be concise. -2.10e+1. What is the average Payments (BoP, current US$) of High income: OECD per year?
Your answer should be very brief. 1.40e+13. What is the average Payments (BoP, current US$) of Bahrain per year?
Make the answer very short. 2.02e+1. What is the average Payments (BoP, current US$) in Belize per year?
Offer a very short reply. 9.84e+08. What is the average Payments (BoP, current US$) of Estonia per year?
Give a very brief answer. 1.75e+1. In the year 2005, what is the difference between the Payments (BoP, current US$) of High income: OECD and Payments (BoP, current US$) of Bahrain?
Offer a terse response. 1.08e+13. In the year 2005, what is the difference between the Payments (BoP, current US$) in High income: OECD and Payments (BoP, current US$) in Belize?
Your response must be concise. 1.08e+13. In the year 2005, what is the difference between the Payments (BoP, current US$) of High income: OECD and Payments (BoP, current US$) of Estonia?
Your answer should be compact. 1.08e+13. In the year 2005, what is the difference between the Payments (BoP, current US$) of Bahrain and Payments (BoP, current US$) of Belize?
Your answer should be very brief. 1.49e+1. In the year 2005, what is the difference between the Payments (BoP, current US$) in Bahrain and Payments (BoP, current US$) in Estonia?
Your answer should be very brief. 3.17e+09. In the year 2005, what is the difference between the Payments (BoP, current US$) in Belize and Payments (BoP, current US$) in Estonia?
Ensure brevity in your answer.  -1.17e+1. In the year 2006, what is the difference between the Payments (BoP, current US$) in High income: OECD and Payments (BoP, current US$) in Bahrain?
Give a very brief answer. 1.25e+13. In the year 2006, what is the difference between the Payments (BoP, current US$) of High income: OECD and Payments (BoP, current US$) of Belize?
Provide a short and direct response. 1.26e+13. In the year 2006, what is the difference between the Payments (BoP, current US$) of High income: OECD and Payments (BoP, current US$) of Estonia?
Keep it short and to the point. 1.25e+13. In the year 2006, what is the difference between the Payments (BoP, current US$) of Bahrain and Payments (BoP, current US$) of Belize?
Keep it short and to the point. 1.87e+1. In the year 2006, what is the difference between the Payments (BoP, current US$) of Bahrain and Payments (BoP, current US$) of Estonia?
Give a very brief answer. 4.00e+09. In the year 2006, what is the difference between the Payments (BoP, current US$) of Belize and Payments (BoP, current US$) of Estonia?
Your answer should be very brief. -1.47e+1. In the year 2007, what is the difference between the Payments (BoP, current US$) in High income: OECD and Payments (BoP, current US$) in Bahrain?
Your answer should be compact. 1.47e+13. In the year 2007, what is the difference between the Payments (BoP, current US$) of High income: OECD and Payments (BoP, current US$) of Belize?
Ensure brevity in your answer.  1.48e+13. In the year 2007, what is the difference between the Payments (BoP, current US$) in High income: OECD and Payments (BoP, current US$) in Estonia?
Make the answer very short. 1.47e+13. In the year 2007, what is the difference between the Payments (BoP, current US$) of Bahrain and Payments (BoP, current US$) of Belize?
Ensure brevity in your answer.  2.23e+1. In the year 2007, what is the difference between the Payments (BoP, current US$) of Bahrain and Payments (BoP, current US$) of Estonia?
Give a very brief answer. 3.61e+09. In the year 2007, what is the difference between the Payments (BoP, current US$) of Belize and Payments (BoP, current US$) of Estonia?
Offer a very short reply. -1.87e+1. In the year 2008, what is the difference between the Payments (BoP, current US$) in High income: OECD and Payments (BoP, current US$) in Bahrain?
Make the answer very short. 1.60e+13. In the year 2008, what is the difference between the Payments (BoP, current US$) of High income: OECD and Payments (BoP, current US$) of Belize?
Your answer should be very brief. 1.61e+13. In the year 2008, what is the difference between the Payments (BoP, current US$) of High income: OECD and Payments (BoP, current US$) of Estonia?
Keep it short and to the point. 1.60e+13. In the year 2008, what is the difference between the Payments (BoP, current US$) in Bahrain and Payments (BoP, current US$) in Belize?
Keep it short and to the point. 2.32e+1. In the year 2008, what is the difference between the Payments (BoP, current US$) in Bahrain and Payments (BoP, current US$) in Estonia?
Ensure brevity in your answer.  3.76e+09. In the year 2008, what is the difference between the Payments (BoP, current US$) of Belize and Payments (BoP, current US$) of Estonia?
Give a very brief answer. -1.94e+1. In the year 2009, what is the difference between the Payments (BoP, current US$) in High income: OECD and Payments (BoP, current US$) in Bahrain?
Your answer should be compact. 1.22e+13. In the year 2009, what is the difference between the Payments (BoP, current US$) of High income: OECD and Payments (BoP, current US$) of Belize?
Provide a short and direct response. 1.22e+13. In the year 2009, what is the difference between the Payments (BoP, current US$) of High income: OECD and Payments (BoP, current US$) of Estonia?
Your answer should be very brief. 1.22e+13. In the year 2009, what is the difference between the Payments (BoP, current US$) in Bahrain and Payments (BoP, current US$) in Belize?
Offer a terse response. 1.45e+1. In the year 2009, what is the difference between the Payments (BoP, current US$) of Bahrain and Payments (BoP, current US$) of Estonia?
Your answer should be compact. 2.58e+09. In the year 2009, what is the difference between the Payments (BoP, current US$) in Belize and Payments (BoP, current US$) in Estonia?
Your answer should be very brief. -1.20e+1. In the year 2010, what is the difference between the Payments (BoP, current US$) of High income: OECD and Payments (BoP, current US$) of Bahrain?
Offer a terse response. 1.38e+13. In the year 2010, what is the difference between the Payments (BoP, current US$) in High income: OECD and Payments (BoP, current US$) in Belize?
Provide a short and direct response. 1.38e+13. In the year 2010, what is the difference between the Payments (BoP, current US$) of High income: OECD and Payments (BoP, current US$) of Estonia?
Provide a short and direct response. 1.38e+13. In the year 2010, what is the difference between the Payments (BoP, current US$) of Bahrain and Payments (BoP, current US$) of Belize?
Your answer should be compact. 1.60e+1. In the year 2010, what is the difference between the Payments (BoP, current US$) of Bahrain and Payments (BoP, current US$) of Estonia?
Give a very brief answer. 1.27e+09. In the year 2010, what is the difference between the Payments (BoP, current US$) of Belize and Payments (BoP, current US$) of Estonia?
Your answer should be very brief. -1.47e+1. In the year 2011, what is the difference between the Payments (BoP, current US$) of High income: OECD and Payments (BoP, current US$) of Bahrain?
Ensure brevity in your answer.  1.60e+13. In the year 2011, what is the difference between the Payments (BoP, current US$) of High income: OECD and Payments (BoP, current US$) of Belize?
Offer a very short reply. 1.60e+13. In the year 2011, what is the difference between the Payments (BoP, current US$) in High income: OECD and Payments (BoP, current US$) in Estonia?
Offer a terse response. 1.60e+13. In the year 2011, what is the difference between the Payments (BoP, current US$) of Bahrain and Payments (BoP, current US$) of Belize?
Offer a very short reply. 2.34e+1. In the year 2011, what is the difference between the Payments (BoP, current US$) in Bahrain and Payments (BoP, current US$) in Estonia?
Offer a terse response. 3.11e+09. In the year 2011, what is the difference between the Payments (BoP, current US$) of Belize and Payments (BoP, current US$) of Estonia?
Keep it short and to the point. -2.03e+1. In the year 2012, what is the difference between the Payments (BoP, current US$) of High income: OECD and Payments (BoP, current US$) of Bahrain?
Offer a terse response. 1.56e+13. In the year 2012, what is the difference between the Payments (BoP, current US$) in High income: OECD and Payments (BoP, current US$) in Belize?
Provide a short and direct response. 1.56e+13. In the year 2012, what is the difference between the Payments (BoP, current US$) of High income: OECD and Payments (BoP, current US$) of Estonia?
Offer a very short reply. 1.56e+13. In the year 2012, what is the difference between the Payments (BoP, current US$) of Bahrain and Payments (BoP, current US$) of Belize?
Ensure brevity in your answer.  2.04e+1. In the year 2012, what is the difference between the Payments (BoP, current US$) in Bahrain and Payments (BoP, current US$) in Estonia?
Your answer should be compact. -5.41e+08. In the year 2012, what is the difference between the Payments (BoP, current US$) of Belize and Payments (BoP, current US$) of Estonia?
Provide a short and direct response. -2.09e+1. What is the ratio of the Payments (BoP, current US$) in High income: OECD in 2005 to that in 2006?
Your answer should be very brief. 0.86. What is the ratio of the Payments (BoP, current US$) of Bahrain in 2005 to that in 2006?
Ensure brevity in your answer.  0.8. What is the ratio of the Payments (BoP, current US$) in Belize in 2005 to that in 2006?
Give a very brief answer. 0.93. What is the ratio of the Payments (BoP, current US$) in Estonia in 2005 to that in 2006?
Provide a succinct answer. 0.81. What is the ratio of the Payments (BoP, current US$) of High income: OECD in 2005 to that in 2007?
Provide a short and direct response. 0.73. What is the ratio of the Payments (BoP, current US$) in Bahrain in 2005 to that in 2007?
Your answer should be compact. 0.67. What is the ratio of the Payments (BoP, current US$) in Belize in 2005 to that in 2007?
Provide a short and direct response. 0.85. What is the ratio of the Payments (BoP, current US$) in Estonia in 2005 to that in 2007?
Ensure brevity in your answer.  0.64. What is the ratio of the Payments (BoP, current US$) of High income: OECD in 2005 to that in 2008?
Keep it short and to the point. 0.67. What is the ratio of the Payments (BoP, current US$) in Bahrain in 2005 to that in 2008?
Provide a succinct answer. 0.65. What is the ratio of the Payments (BoP, current US$) of Belize in 2005 to that in 2008?
Offer a very short reply. 0.73. What is the ratio of the Payments (BoP, current US$) of Estonia in 2005 to that in 2008?
Provide a short and direct response. 0.61. What is the ratio of the Payments (BoP, current US$) in High income: OECD in 2005 to that in 2009?
Offer a very short reply. 0.88. What is the ratio of the Payments (BoP, current US$) of Bahrain in 2005 to that in 2009?
Make the answer very short. 1.02. What is the ratio of the Payments (BoP, current US$) of Belize in 2005 to that in 2009?
Offer a very short reply. 0.92. What is the ratio of the Payments (BoP, current US$) in Estonia in 2005 to that in 2009?
Provide a short and direct response. 0.98. What is the ratio of the Payments (BoP, current US$) in High income: OECD in 2005 to that in 2010?
Your answer should be compact. 0.78. What is the ratio of the Payments (BoP, current US$) in Bahrain in 2005 to that in 2010?
Offer a very short reply. 0.93. What is the ratio of the Payments (BoP, current US$) in Belize in 2005 to that in 2010?
Provide a short and direct response. 0.85. What is the ratio of the Payments (BoP, current US$) in Estonia in 2005 to that in 2010?
Give a very brief answer. 0.8. What is the ratio of the Payments (BoP, current US$) of High income: OECD in 2005 to that in 2011?
Provide a short and direct response. 0.68. What is the ratio of the Payments (BoP, current US$) in Bahrain in 2005 to that in 2011?
Your answer should be very brief. 0.64. What is the ratio of the Payments (BoP, current US$) in Belize in 2005 to that in 2011?
Ensure brevity in your answer.  0.78. What is the ratio of the Payments (BoP, current US$) of Estonia in 2005 to that in 2011?
Your response must be concise. 0.59. What is the ratio of the Payments (BoP, current US$) in High income: OECD in 2005 to that in 2012?
Your answer should be very brief. 0.69. What is the ratio of the Payments (BoP, current US$) in Bahrain in 2005 to that in 2012?
Offer a terse response. 0.73. What is the ratio of the Payments (BoP, current US$) of Belize in 2005 to that in 2012?
Provide a succinct answer. 0.72. What is the ratio of the Payments (BoP, current US$) in Estonia in 2005 to that in 2012?
Provide a short and direct response. 0.57. What is the ratio of the Payments (BoP, current US$) of High income: OECD in 2006 to that in 2007?
Your response must be concise. 0.85. What is the ratio of the Payments (BoP, current US$) of Bahrain in 2006 to that in 2007?
Offer a terse response. 0.84. What is the ratio of the Payments (BoP, current US$) of Belize in 2006 to that in 2007?
Provide a succinct answer. 0.91. What is the ratio of the Payments (BoP, current US$) in Estonia in 2006 to that in 2007?
Keep it short and to the point. 0.79. What is the ratio of the Payments (BoP, current US$) of High income: OECD in 2006 to that in 2008?
Make the answer very short. 0.78. What is the ratio of the Payments (BoP, current US$) of Bahrain in 2006 to that in 2008?
Provide a short and direct response. 0.81. What is the ratio of the Payments (BoP, current US$) in Belize in 2006 to that in 2008?
Ensure brevity in your answer.  0.78. What is the ratio of the Payments (BoP, current US$) in Estonia in 2006 to that in 2008?
Ensure brevity in your answer.  0.76. What is the ratio of the Payments (BoP, current US$) in High income: OECD in 2006 to that in 2009?
Keep it short and to the point. 1.03. What is the ratio of the Payments (BoP, current US$) in Bahrain in 2006 to that in 2009?
Offer a terse response. 1.27. What is the ratio of the Payments (BoP, current US$) in Belize in 2006 to that in 2009?
Your answer should be very brief. 0.99. What is the ratio of the Payments (BoP, current US$) of Estonia in 2006 to that in 2009?
Offer a terse response. 1.21. What is the ratio of the Payments (BoP, current US$) of High income: OECD in 2006 to that in 2010?
Keep it short and to the point. 0.91. What is the ratio of the Payments (BoP, current US$) of Bahrain in 2006 to that in 2010?
Ensure brevity in your answer.  1.16. What is the ratio of the Payments (BoP, current US$) in Belize in 2006 to that in 2010?
Ensure brevity in your answer.  0.91. What is the ratio of the Payments (BoP, current US$) of Estonia in 2006 to that in 2010?
Ensure brevity in your answer.  0.99. What is the ratio of the Payments (BoP, current US$) of High income: OECD in 2006 to that in 2011?
Your answer should be very brief. 0.79. What is the ratio of the Payments (BoP, current US$) of Bahrain in 2006 to that in 2011?
Give a very brief answer. 0.8. What is the ratio of the Payments (BoP, current US$) of Belize in 2006 to that in 2011?
Keep it short and to the point. 0.84. What is the ratio of the Payments (BoP, current US$) in Estonia in 2006 to that in 2011?
Offer a terse response. 0.73. What is the ratio of the Payments (BoP, current US$) of High income: OECD in 2006 to that in 2012?
Your answer should be compact. 0.8. What is the ratio of the Payments (BoP, current US$) of Bahrain in 2006 to that in 2012?
Provide a short and direct response. 0.91. What is the ratio of the Payments (BoP, current US$) in Belize in 2006 to that in 2012?
Your answer should be compact. 0.77. What is the ratio of the Payments (BoP, current US$) in Estonia in 2006 to that in 2012?
Make the answer very short. 0.7. What is the ratio of the Payments (BoP, current US$) in High income: OECD in 2007 to that in 2008?
Ensure brevity in your answer.  0.92. What is the ratio of the Payments (BoP, current US$) in Bahrain in 2007 to that in 2008?
Make the answer very short. 0.96. What is the ratio of the Payments (BoP, current US$) in Belize in 2007 to that in 2008?
Ensure brevity in your answer.  0.86. What is the ratio of the Payments (BoP, current US$) in Estonia in 2007 to that in 2008?
Keep it short and to the point. 0.96. What is the ratio of the Payments (BoP, current US$) in High income: OECD in 2007 to that in 2009?
Provide a succinct answer. 1.21. What is the ratio of the Payments (BoP, current US$) of Bahrain in 2007 to that in 2009?
Your response must be concise. 1.51. What is the ratio of the Payments (BoP, current US$) of Belize in 2007 to that in 2009?
Make the answer very short. 1.08. What is the ratio of the Payments (BoP, current US$) in Estonia in 2007 to that in 2009?
Offer a terse response. 1.53. What is the ratio of the Payments (BoP, current US$) in High income: OECD in 2007 to that in 2010?
Give a very brief answer. 1.07. What is the ratio of the Payments (BoP, current US$) of Bahrain in 2007 to that in 2010?
Keep it short and to the point. 1.38. What is the ratio of the Payments (BoP, current US$) in Estonia in 2007 to that in 2010?
Provide a succinct answer. 1.26. What is the ratio of the Payments (BoP, current US$) of High income: OECD in 2007 to that in 2011?
Give a very brief answer. 0.92. What is the ratio of the Payments (BoP, current US$) in Bahrain in 2007 to that in 2011?
Your answer should be very brief. 0.95. What is the ratio of the Payments (BoP, current US$) of Belize in 2007 to that in 2011?
Your answer should be compact. 0.92. What is the ratio of the Payments (BoP, current US$) of Estonia in 2007 to that in 2011?
Make the answer very short. 0.92. What is the ratio of the Payments (BoP, current US$) in High income: OECD in 2007 to that in 2012?
Your answer should be compact. 0.94. What is the ratio of the Payments (BoP, current US$) in Bahrain in 2007 to that in 2012?
Provide a short and direct response. 1.08. What is the ratio of the Payments (BoP, current US$) of Belize in 2007 to that in 2012?
Provide a short and direct response. 0.84. What is the ratio of the Payments (BoP, current US$) of Estonia in 2007 to that in 2012?
Make the answer very short. 0.89. What is the ratio of the Payments (BoP, current US$) of High income: OECD in 2008 to that in 2009?
Ensure brevity in your answer.  1.31. What is the ratio of the Payments (BoP, current US$) of Bahrain in 2008 to that in 2009?
Offer a terse response. 1.57. What is the ratio of the Payments (BoP, current US$) of Belize in 2008 to that in 2009?
Offer a terse response. 1.26. What is the ratio of the Payments (BoP, current US$) of Estonia in 2008 to that in 2009?
Provide a succinct answer. 1.6. What is the ratio of the Payments (BoP, current US$) in High income: OECD in 2008 to that in 2010?
Make the answer very short. 1.17. What is the ratio of the Payments (BoP, current US$) in Bahrain in 2008 to that in 2010?
Your response must be concise. 1.43. What is the ratio of the Payments (BoP, current US$) in Belize in 2008 to that in 2010?
Provide a short and direct response. 1.16. What is the ratio of the Payments (BoP, current US$) in Estonia in 2008 to that in 2010?
Provide a short and direct response. 1.31. What is the ratio of the Payments (BoP, current US$) in Bahrain in 2008 to that in 2011?
Your response must be concise. 0.99. What is the ratio of the Payments (BoP, current US$) of Belize in 2008 to that in 2011?
Give a very brief answer. 1.07. What is the ratio of the Payments (BoP, current US$) of Estonia in 2008 to that in 2011?
Provide a short and direct response. 0.96. What is the ratio of the Payments (BoP, current US$) of High income: OECD in 2008 to that in 2012?
Offer a very short reply. 1.03. What is the ratio of the Payments (BoP, current US$) of Bahrain in 2008 to that in 2012?
Give a very brief answer. 1.13. What is the ratio of the Payments (BoP, current US$) of Belize in 2008 to that in 2012?
Provide a succinct answer. 0.98. What is the ratio of the Payments (BoP, current US$) of Estonia in 2008 to that in 2012?
Provide a succinct answer. 0.93. What is the ratio of the Payments (BoP, current US$) in High income: OECD in 2009 to that in 2010?
Provide a short and direct response. 0.89. What is the ratio of the Payments (BoP, current US$) in Bahrain in 2009 to that in 2010?
Ensure brevity in your answer.  0.91. What is the ratio of the Payments (BoP, current US$) of Belize in 2009 to that in 2010?
Provide a succinct answer. 0.92. What is the ratio of the Payments (BoP, current US$) in Estonia in 2009 to that in 2010?
Provide a succinct answer. 0.82. What is the ratio of the Payments (BoP, current US$) in High income: OECD in 2009 to that in 2011?
Your answer should be very brief. 0.77. What is the ratio of the Payments (BoP, current US$) of Bahrain in 2009 to that in 2011?
Offer a terse response. 0.63. What is the ratio of the Payments (BoP, current US$) in Belize in 2009 to that in 2011?
Your answer should be very brief. 0.85. What is the ratio of the Payments (BoP, current US$) in Estonia in 2009 to that in 2011?
Provide a short and direct response. 0.6. What is the ratio of the Payments (BoP, current US$) of High income: OECD in 2009 to that in 2012?
Offer a terse response. 0.78. What is the ratio of the Payments (BoP, current US$) of Bahrain in 2009 to that in 2012?
Offer a very short reply. 0.72. What is the ratio of the Payments (BoP, current US$) of Belize in 2009 to that in 2012?
Give a very brief answer. 0.78. What is the ratio of the Payments (BoP, current US$) in Estonia in 2009 to that in 2012?
Your answer should be very brief. 0.58. What is the ratio of the Payments (BoP, current US$) of High income: OECD in 2010 to that in 2011?
Provide a short and direct response. 0.86. What is the ratio of the Payments (BoP, current US$) of Bahrain in 2010 to that in 2011?
Offer a terse response. 0.69. What is the ratio of the Payments (BoP, current US$) in Belize in 2010 to that in 2011?
Ensure brevity in your answer.  0.92. What is the ratio of the Payments (BoP, current US$) of Estonia in 2010 to that in 2011?
Make the answer very short. 0.73. What is the ratio of the Payments (BoP, current US$) in High income: OECD in 2010 to that in 2012?
Your answer should be compact. 0.88. What is the ratio of the Payments (BoP, current US$) of Bahrain in 2010 to that in 2012?
Provide a succinct answer. 0.79. What is the ratio of the Payments (BoP, current US$) of Belize in 2010 to that in 2012?
Keep it short and to the point. 0.85. What is the ratio of the Payments (BoP, current US$) of Estonia in 2010 to that in 2012?
Make the answer very short. 0.71. What is the ratio of the Payments (BoP, current US$) in High income: OECD in 2011 to that in 2012?
Make the answer very short. 1.02. What is the ratio of the Payments (BoP, current US$) in Bahrain in 2011 to that in 2012?
Your answer should be very brief. 1.14. What is the ratio of the Payments (BoP, current US$) of Belize in 2011 to that in 2012?
Provide a short and direct response. 0.92. What is the ratio of the Payments (BoP, current US$) of Estonia in 2011 to that in 2012?
Offer a very short reply. 0.97. What is the difference between the highest and the second highest Payments (BoP, current US$) of High income: OECD?
Give a very brief answer. 8.32e+1. What is the difference between the highest and the second highest Payments (BoP, current US$) in Bahrain?
Make the answer very short. 1.82e+08. What is the difference between the highest and the second highest Payments (BoP, current US$) in Belize?
Your answer should be compact. 1.95e+07. What is the difference between the highest and the second highest Payments (BoP, current US$) in Estonia?
Provide a succinct answer. 7.37e+08. What is the difference between the highest and the lowest Payments (BoP, current US$) of High income: OECD?
Give a very brief answer. 5.27e+12. What is the difference between the highest and the lowest Payments (BoP, current US$) of Bahrain?
Keep it short and to the point. 9.04e+09. What is the difference between the highest and the lowest Payments (BoP, current US$) of Belize?
Your answer should be compact. 3.24e+08. What is the difference between the highest and the lowest Payments (BoP, current US$) in Estonia?
Your answer should be compact. 9.55e+09. 